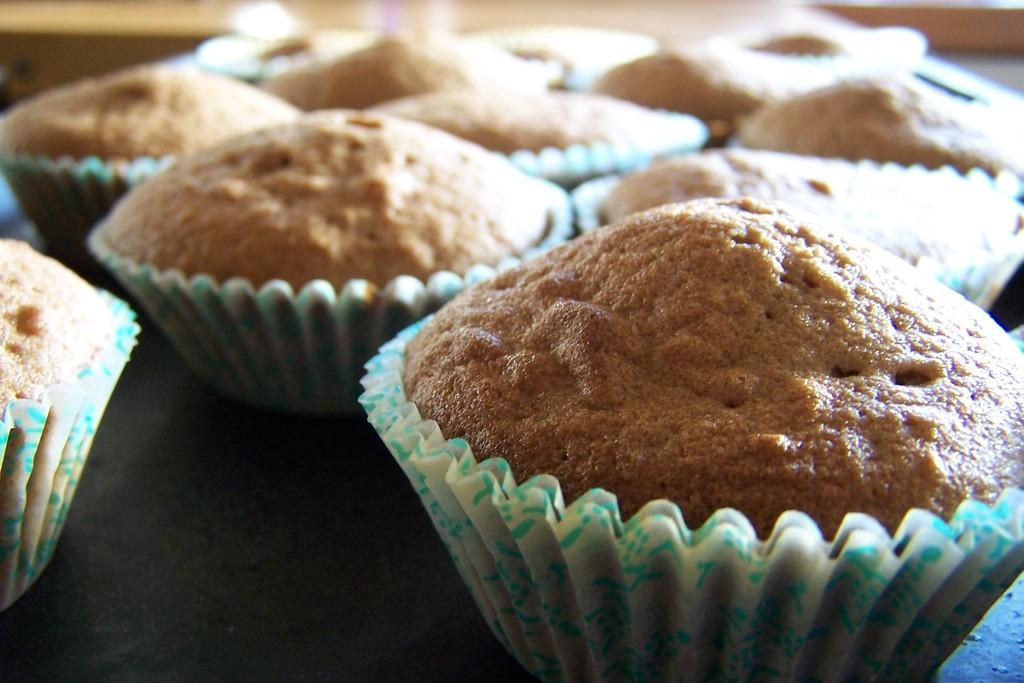Can you describe this image briefly? In this image there are cupcakes on the table. 